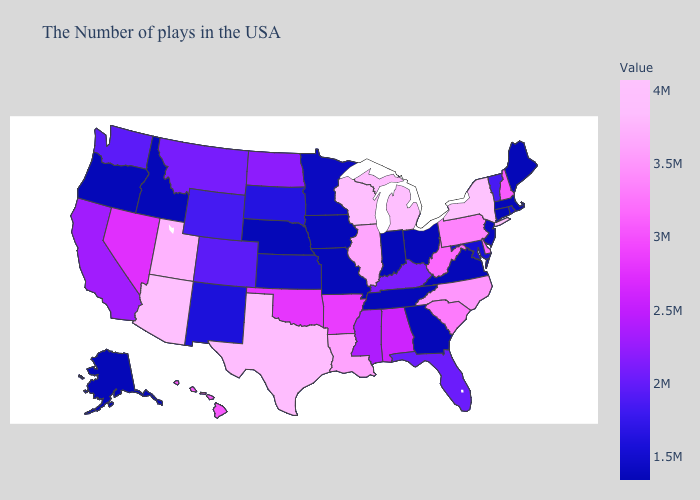Among the states that border Pennsylvania , which have the lowest value?
Give a very brief answer. Ohio. 